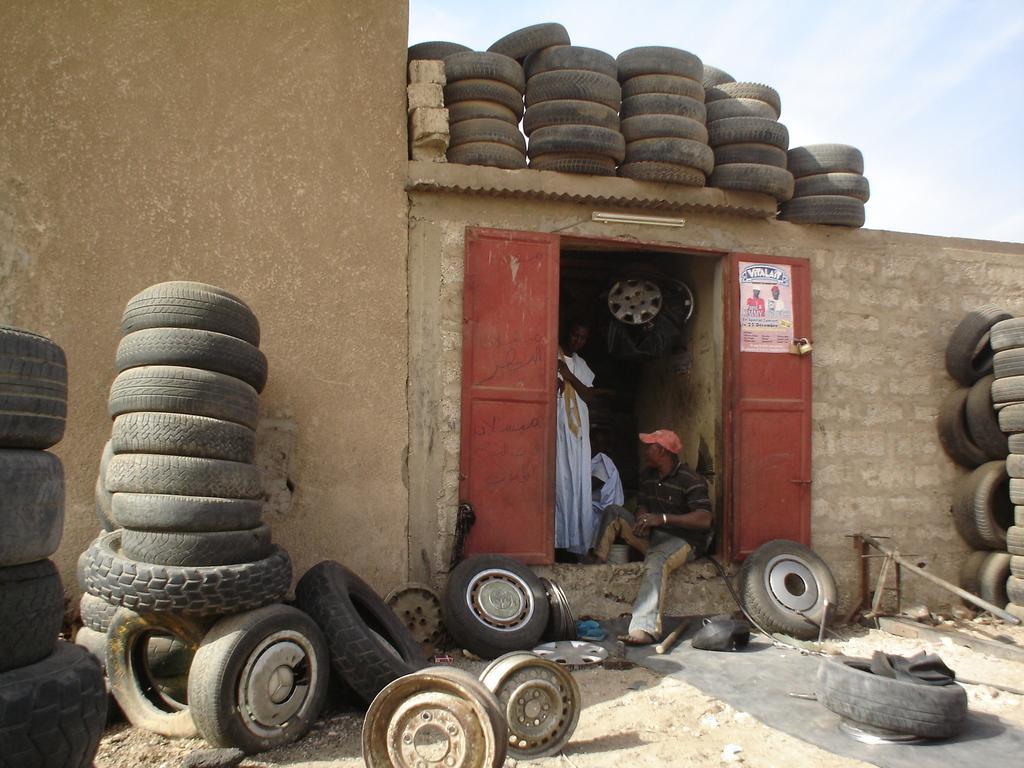How would you summarize this image in a sentence or two? This image consists of a room. There are two persons in that. There are tires in this image. There is sky at the top. 